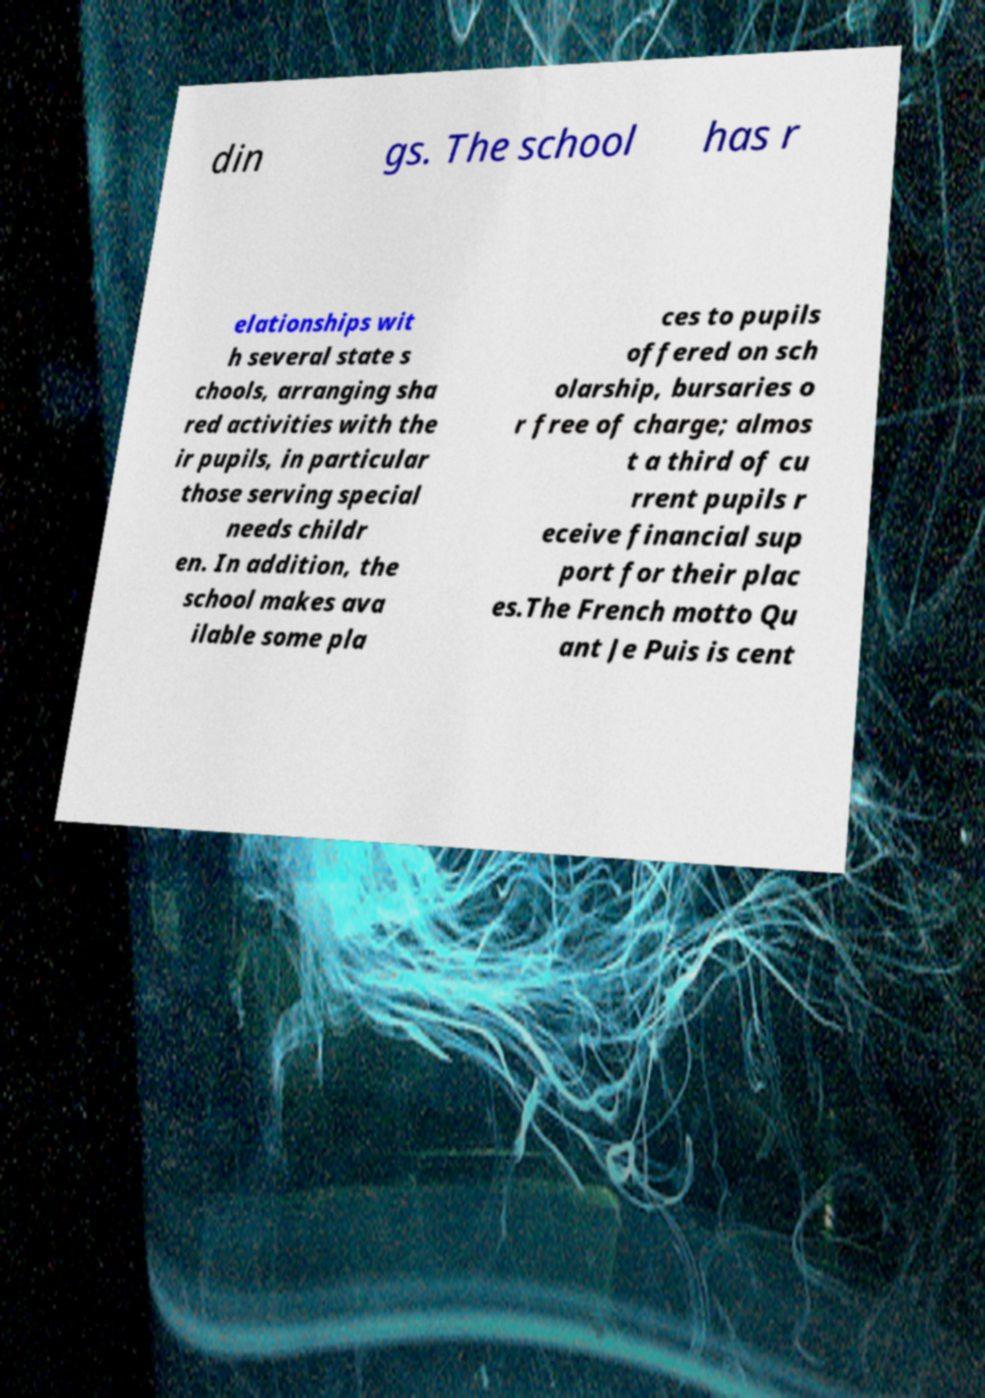Please read and relay the text visible in this image. What does it say? din gs. The school has r elationships wit h several state s chools, arranging sha red activities with the ir pupils, in particular those serving special needs childr en. In addition, the school makes ava ilable some pla ces to pupils offered on sch olarship, bursaries o r free of charge; almos t a third of cu rrent pupils r eceive financial sup port for their plac es.The French motto Qu ant Je Puis is cent 